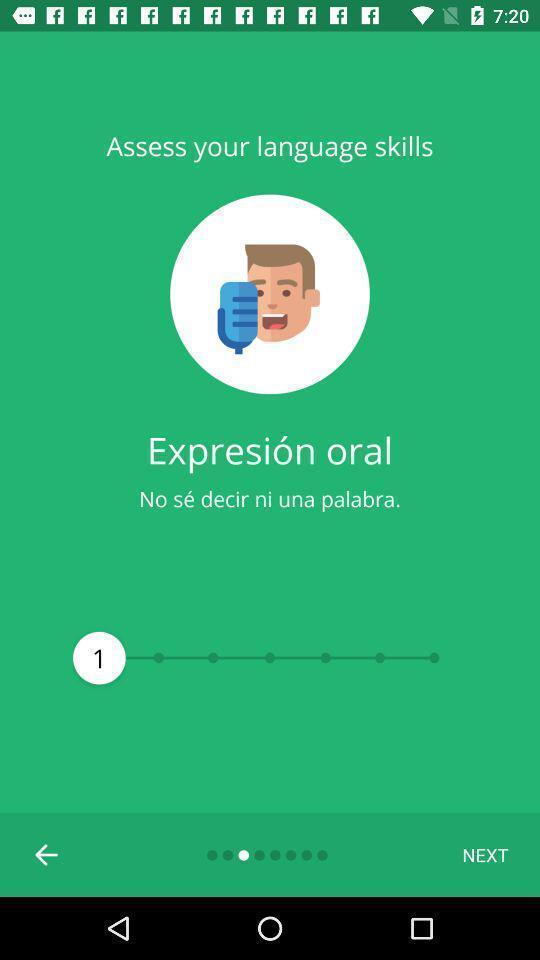Give me a narrative description of this picture. Welcome page of a learning app. 